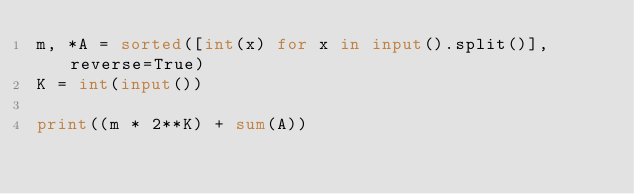<code> <loc_0><loc_0><loc_500><loc_500><_Python_>m, *A = sorted([int(x) for x in input().split()], reverse=True)
K = int(input())
  
print((m * 2**K) + sum(A))</code> 